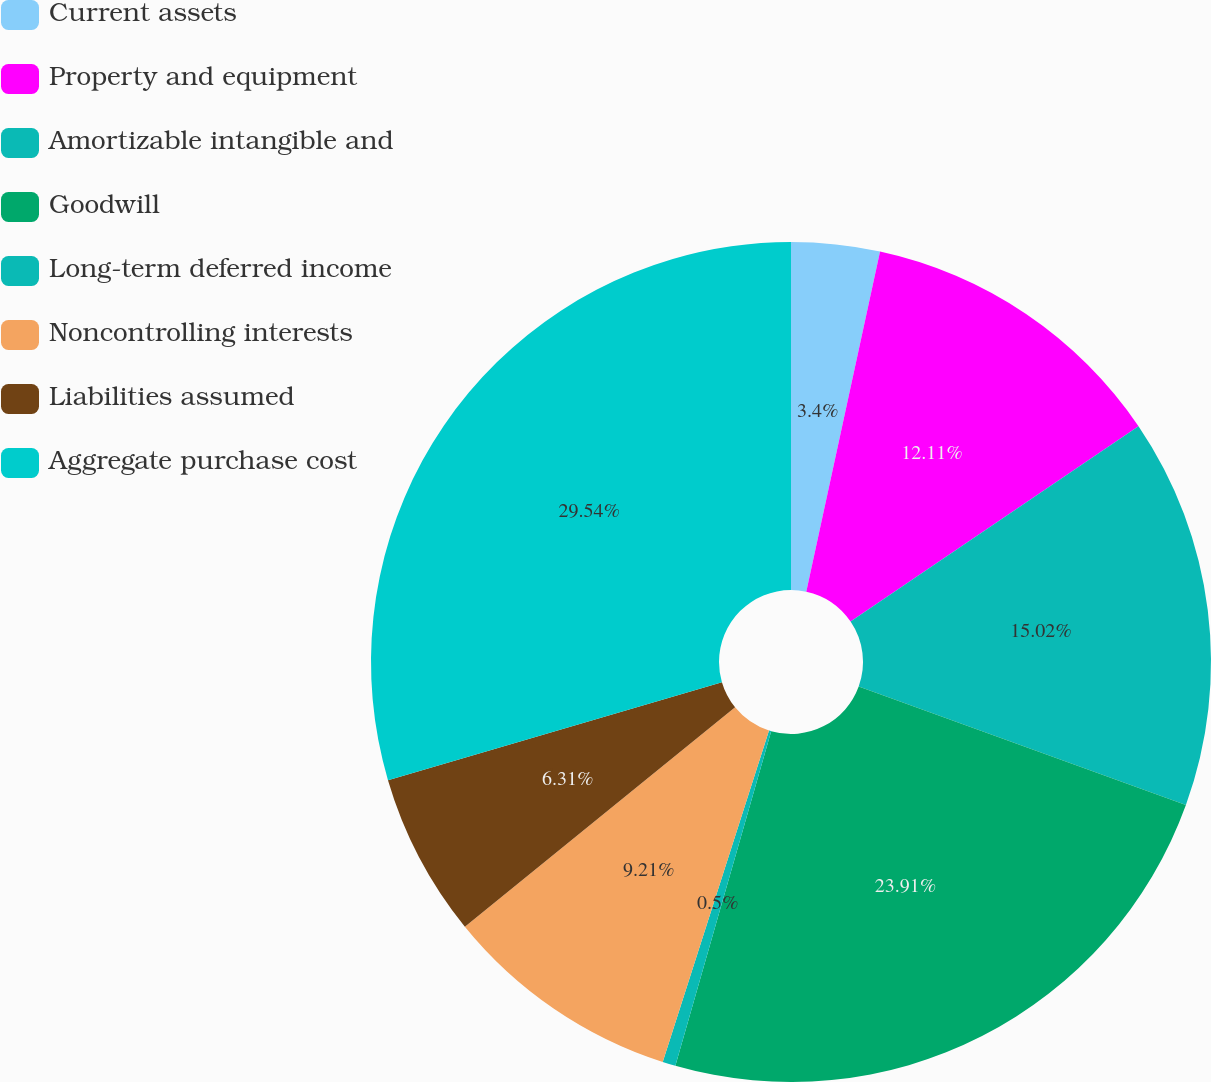Convert chart to OTSL. <chart><loc_0><loc_0><loc_500><loc_500><pie_chart><fcel>Current assets<fcel>Property and equipment<fcel>Amortizable intangible and<fcel>Goodwill<fcel>Long-term deferred income<fcel>Noncontrolling interests<fcel>Liabilities assumed<fcel>Aggregate purchase cost<nl><fcel>3.4%<fcel>12.11%<fcel>15.02%<fcel>23.91%<fcel>0.5%<fcel>9.21%<fcel>6.31%<fcel>29.54%<nl></chart> 